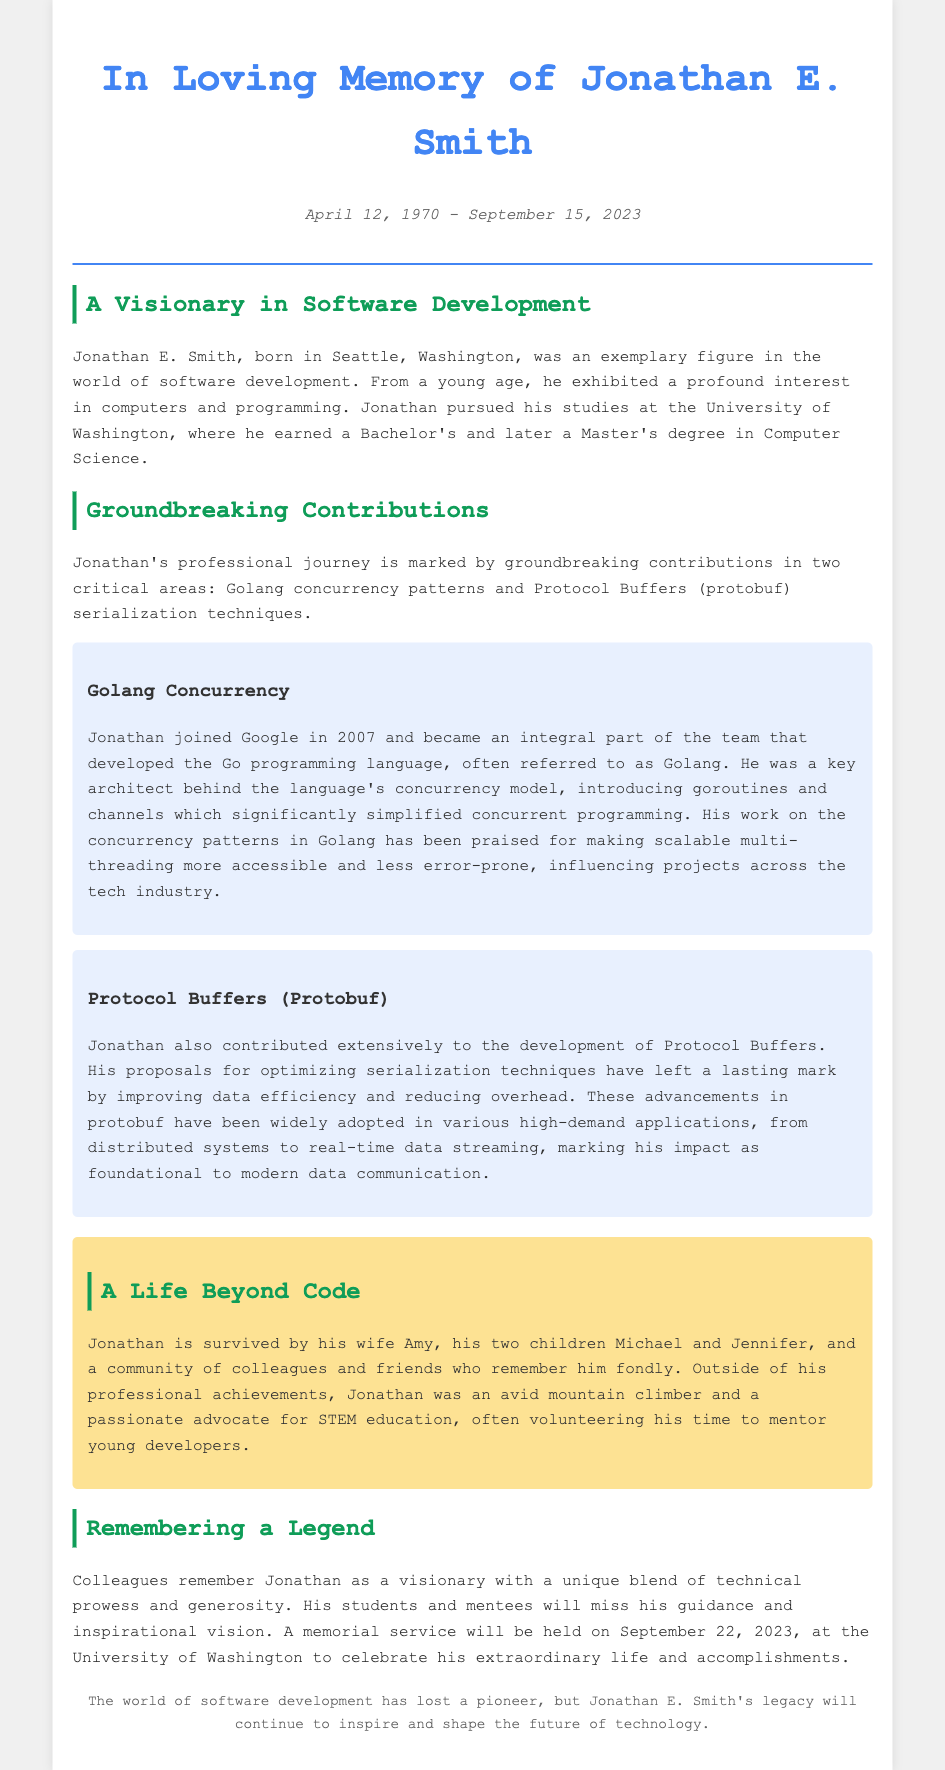What is the full name of the person being commemorated? The full name is mentioned in the title of the document as Jonathan E. Smith.
Answer: Jonathan E. Smith When was Jonathan E. Smith born? The document states his birth date in the date section, which is April 12, 1970.
Answer: April 12, 1970 When did Jonathan E. Smith pass away? The date of Jonathan's passing is specified in the dates section of the document, which is September 15, 2023.
Answer: September 15, 2023 What programming language was Jonathan a key architect of? The document specifically mentions his role in the development of the Go programming language, also known as Golang.
Answer: Go programming language (Golang) What was one of Jonathan's contributions to Protocol Buffers? The document states that he proposed optimizations for serialization techniques in Protocol Buffers, which highlights one of his significant contributions.
Answer: Optimizing serialization techniques What are the names of Jonathan's children? The document lists his children by name, which are mentioned in the personal section as Michael and Jennifer.
Answer: Michael and Jennifer What advocacy was Jonathan involved in outside of his professional career? The document mentions that Jonathan was a passionate advocate for STEM education, indicating his involvement in this cause.
Answer: STEM education What event is planned to honor Jonathan's life? The document indicates that a memorial service is set to be held to celebrate his life and accomplishments on September 22, 2023.
Answer: Memorial service on September 22, 2023 How did colleagues view Jonathan's character? The document describes Jonathan as a visionary with a unique blend of technical prowess and generosity, reflecting how colleagues remembered him.
Answer: Visionary with technical prowess and generosity 